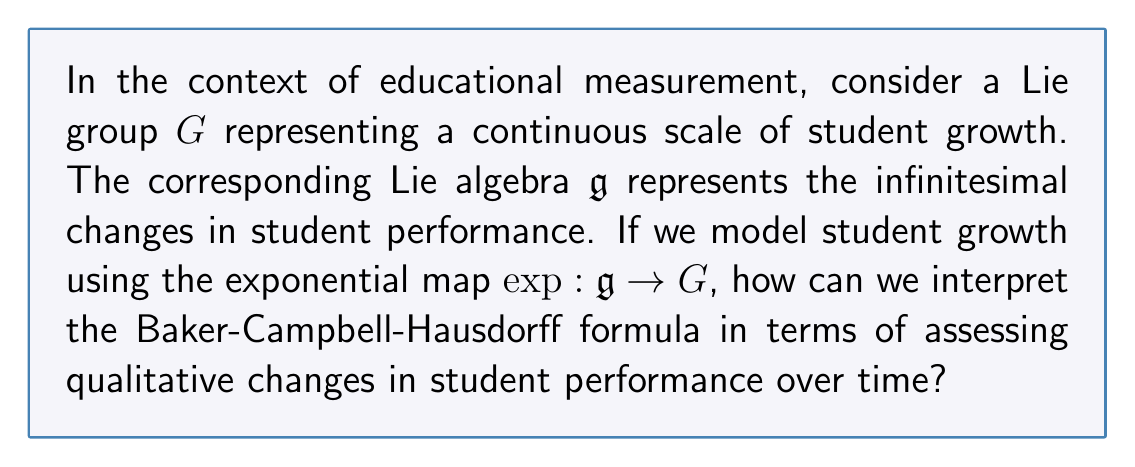Help me with this question. To understand this question in the context of educational measurement and qualitative assessment, let's break it down step-by-step:

1. Lie group $G$ as a continuous scale of student growth:
   We can think of $G$ as representing the overall trajectory of a student's growth. Each point in $G$ corresponds to a specific level of achievement or development.

2. Lie algebra $\mathfrak{g}$ as infinitesimal changes:
   The Lie algebra $\mathfrak{g}$ represents small, incremental changes in student performance. These could be daily improvements, small learning gains, or subtle shifts in understanding.

3. Exponential map $\exp: \mathfrak{g} \to G$:
   This map takes the small changes (elements of $\mathfrak{g}$) and translates them into overall growth (elements of $G$). In educational terms, it's how we aggregate small learning gains into larger, measurable progress.

4. Baker-Campbell-Hausdorff (BCH) formula:
   The BCH formula is given by:
   
   $$\exp(X)\exp(Y) = \exp(X + Y + \frac{1}{2}[X,Y] + \frac{1}{12}([X,[X,Y]] - [Y,[X,Y]]) + \cdots)$$

   where $X$ and $Y$ are elements of the Lie algebra $\mathfrak{g}$, and $[X,Y]$ denotes the Lie bracket.

5. Interpretation in educational measurement:
   - $X$ and $Y$ represent different aspects or periods of student learning.
   - $\exp(X)$ and $\exp(Y)$ are the individual growth from these aspects.
   - The left side, $\exp(X)\exp(Y)$, represents sequential growth.
   - The right side shows how these combine, with additional terms reflecting interactions.

6. Qualitative assessment interpretation:
   - The linear terms $X + Y$ represent simple addition of learning gains.
   - The non-linear terms (those involving brackets) represent how different aspects of learning interact and potentially enhance or interfere with each other.
   - This provides a framework for understanding how different learning experiences combine in non-trivial ways to produce overall growth.

In the context of qualitative assessment, the BCH formula suggests that student growth is not just a simple sum of individual learning experiences. Instead, it's a complex interaction where different aspects of learning can amplify or diminish each other, providing a richer understanding of student development over time.
Answer: The Baker-Campbell-Hausdorff formula in this context can be interpreted as a mathematical representation of how different aspects of student learning interact and combine non-linearly to produce overall growth. It suggests that qualitative assessment should consider not just individual learning gains, but also how these gains interact and potentially enhance or interfere with each other over time. 